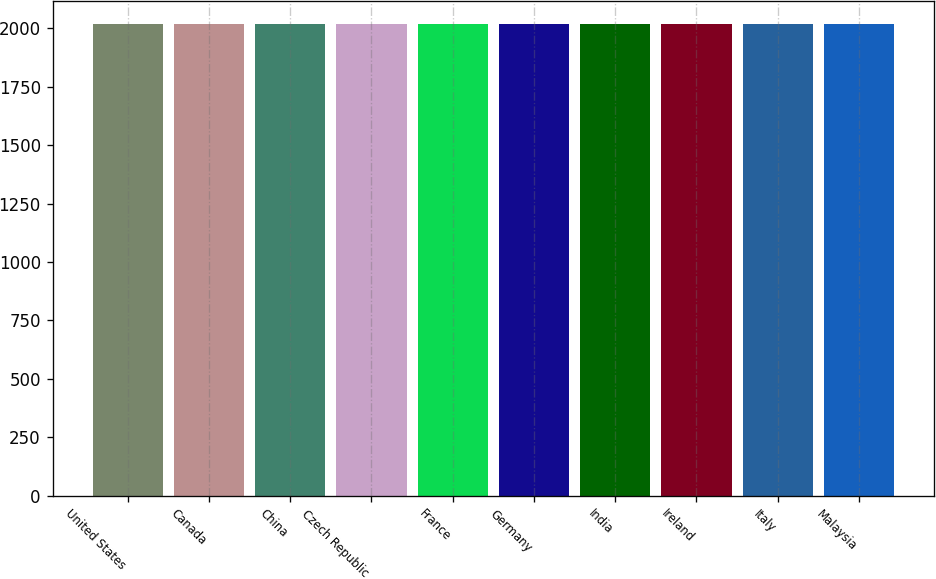Convert chart to OTSL. <chart><loc_0><loc_0><loc_500><loc_500><bar_chart><fcel>United States<fcel>Canada<fcel>China<fcel>Czech Republic<fcel>France<fcel>Germany<fcel>India<fcel>Ireland<fcel>Italy<fcel>Malaysia<nl><fcel>2017<fcel>2017.1<fcel>2017.2<fcel>2017.3<fcel>2017.4<fcel>2017.5<fcel>2017.6<fcel>2017.7<fcel>2017.8<fcel>2017.9<nl></chart> 